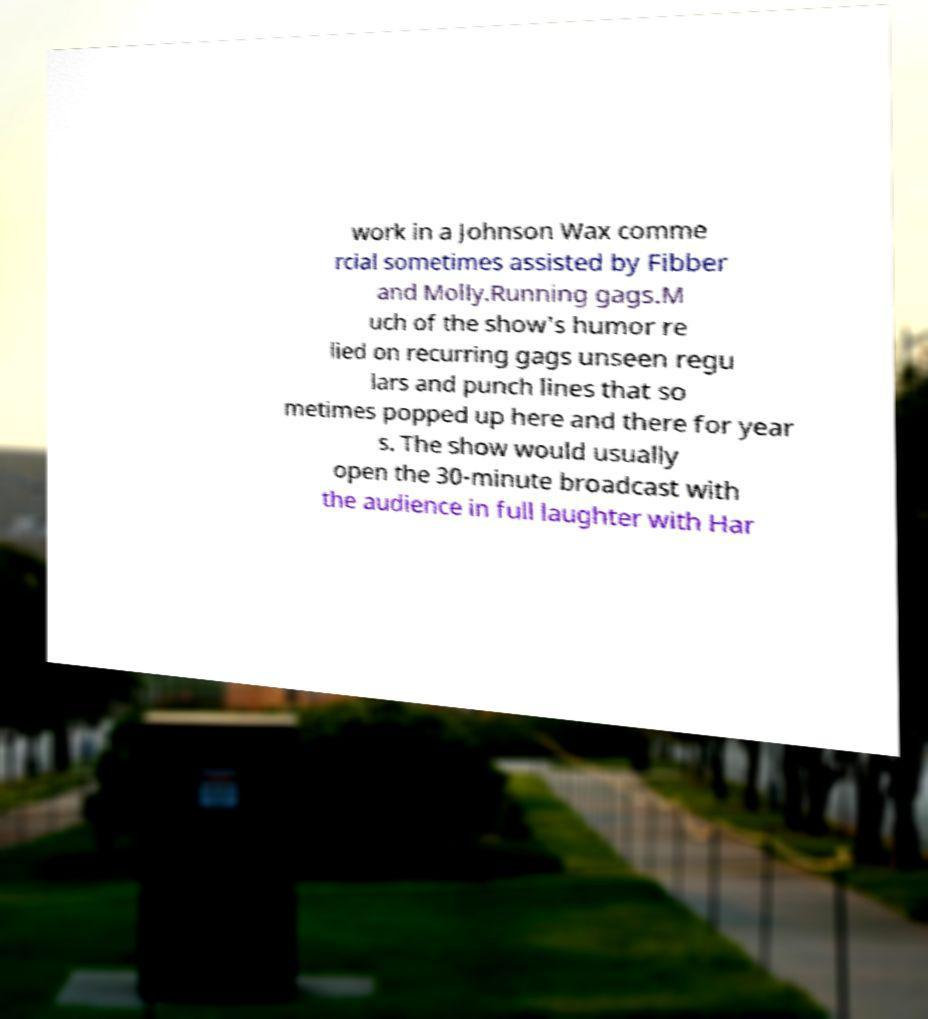Please identify and transcribe the text found in this image. work in a Johnson Wax comme rcial sometimes assisted by Fibber and Molly.Running gags.M uch of the show's humor re lied on recurring gags unseen regu lars and punch lines that so metimes popped up here and there for year s. The show would usually open the 30-minute broadcast with the audience in full laughter with Har 